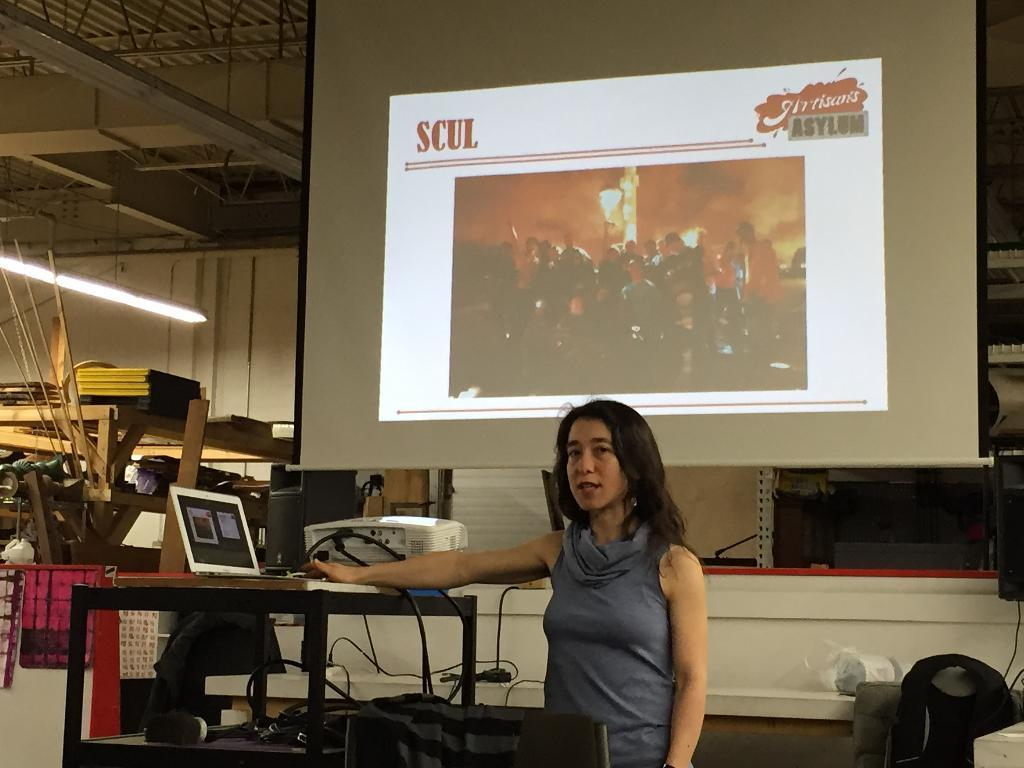Provide a one-sentence caption for the provided image. A woman is giving a presentation with a slide on the projector that says SCUL. 